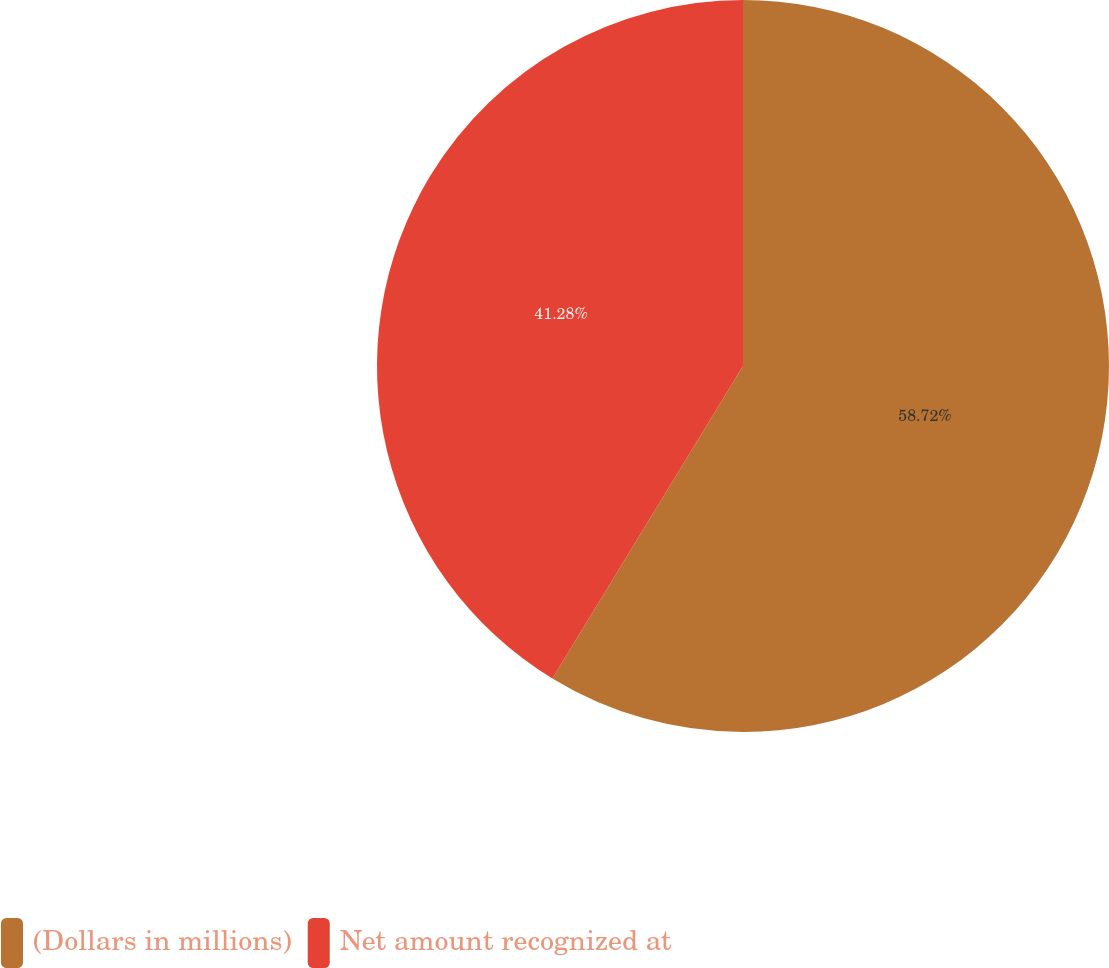Convert chart to OTSL. <chart><loc_0><loc_0><loc_500><loc_500><pie_chart><fcel>(Dollars in millions)<fcel>Net amount recognized at<nl><fcel>58.72%<fcel>41.28%<nl></chart> 